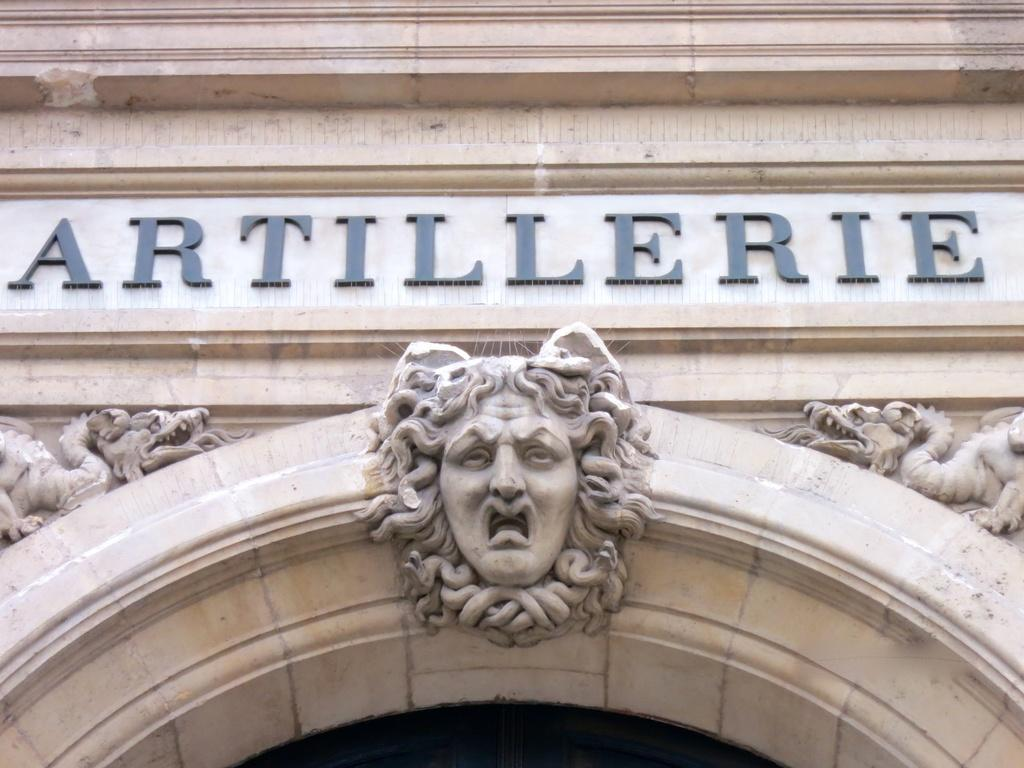What type of structure is visible in the image? There is a wall of a building in the image. What is written or depicted on the wall? There is text on the wall. What architectural feature can be seen in the image? There is an arch in the image. What is attached to the arch? There are statues attached to the arch. In which direction are the statues facing on the arch? The provided facts do not mention the direction the statues are facing, so it cannot be determined from the image. 